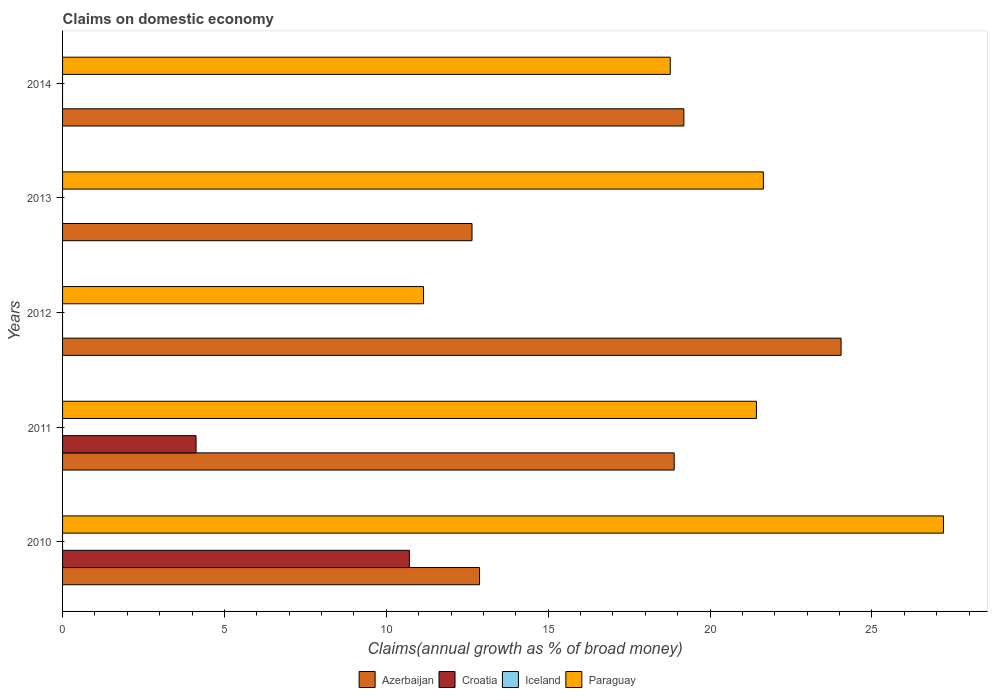How many groups of bars are there?
Give a very brief answer. 5. Are the number of bars per tick equal to the number of legend labels?
Offer a terse response. No. Are the number of bars on each tick of the Y-axis equal?
Your answer should be very brief. No. How many bars are there on the 3rd tick from the top?
Provide a succinct answer. 2. What is the label of the 1st group of bars from the top?
Your answer should be very brief. 2014. What is the percentage of broad money claimed on domestic economy in Azerbaijan in 2013?
Give a very brief answer. 12.65. Across all years, what is the maximum percentage of broad money claimed on domestic economy in Paraguay?
Offer a very short reply. 27.21. Across all years, what is the minimum percentage of broad money claimed on domestic economy in Paraguay?
Provide a short and direct response. 11.15. In which year was the percentage of broad money claimed on domestic economy in Azerbaijan maximum?
Offer a very short reply. 2012. What is the difference between the percentage of broad money claimed on domestic economy in Azerbaijan in 2010 and that in 2012?
Provide a short and direct response. -11.17. What is the difference between the percentage of broad money claimed on domestic economy in Croatia in 2010 and the percentage of broad money claimed on domestic economy in Azerbaijan in 2012?
Provide a succinct answer. -13.33. What is the average percentage of broad money claimed on domestic economy in Paraguay per year?
Your answer should be very brief. 20.04. In the year 2010, what is the difference between the percentage of broad money claimed on domestic economy in Paraguay and percentage of broad money claimed on domestic economy in Croatia?
Your response must be concise. 16.5. In how many years, is the percentage of broad money claimed on domestic economy in Iceland greater than 11 %?
Your response must be concise. 0. What is the ratio of the percentage of broad money claimed on domestic economy in Azerbaijan in 2010 to that in 2013?
Offer a terse response. 1.02. What is the difference between the highest and the second highest percentage of broad money claimed on domestic economy in Azerbaijan?
Ensure brevity in your answer.  4.86. What is the difference between the highest and the lowest percentage of broad money claimed on domestic economy in Paraguay?
Provide a short and direct response. 16.06. In how many years, is the percentage of broad money claimed on domestic economy in Azerbaijan greater than the average percentage of broad money claimed on domestic economy in Azerbaijan taken over all years?
Offer a terse response. 3. Is it the case that in every year, the sum of the percentage of broad money claimed on domestic economy in Iceland and percentage of broad money claimed on domestic economy in Paraguay is greater than the sum of percentage of broad money claimed on domestic economy in Azerbaijan and percentage of broad money claimed on domestic economy in Croatia?
Give a very brief answer. No. Are the values on the major ticks of X-axis written in scientific E-notation?
Your answer should be very brief. No. Does the graph contain any zero values?
Keep it short and to the point. Yes. Does the graph contain grids?
Keep it short and to the point. No. Where does the legend appear in the graph?
Make the answer very short. Bottom center. How are the legend labels stacked?
Give a very brief answer. Horizontal. What is the title of the graph?
Give a very brief answer. Claims on domestic economy. Does "Bahamas" appear as one of the legend labels in the graph?
Give a very brief answer. No. What is the label or title of the X-axis?
Your answer should be compact. Claims(annual growth as % of broad money). What is the Claims(annual growth as % of broad money) of Azerbaijan in 2010?
Keep it short and to the point. 12.88. What is the Claims(annual growth as % of broad money) of Croatia in 2010?
Ensure brevity in your answer.  10.71. What is the Claims(annual growth as % of broad money) of Iceland in 2010?
Your response must be concise. 0. What is the Claims(annual growth as % of broad money) of Paraguay in 2010?
Ensure brevity in your answer.  27.21. What is the Claims(annual growth as % of broad money) of Azerbaijan in 2011?
Keep it short and to the point. 18.89. What is the Claims(annual growth as % of broad money) in Croatia in 2011?
Keep it short and to the point. 4.12. What is the Claims(annual growth as % of broad money) in Paraguay in 2011?
Provide a succinct answer. 21.43. What is the Claims(annual growth as % of broad money) in Azerbaijan in 2012?
Provide a succinct answer. 24.05. What is the Claims(annual growth as % of broad money) in Croatia in 2012?
Your response must be concise. 0. What is the Claims(annual growth as % of broad money) of Paraguay in 2012?
Your answer should be compact. 11.15. What is the Claims(annual growth as % of broad money) in Azerbaijan in 2013?
Keep it short and to the point. 12.65. What is the Claims(annual growth as % of broad money) in Croatia in 2013?
Provide a short and direct response. 0. What is the Claims(annual growth as % of broad money) of Iceland in 2013?
Provide a succinct answer. 0. What is the Claims(annual growth as % of broad money) in Paraguay in 2013?
Ensure brevity in your answer.  21.65. What is the Claims(annual growth as % of broad money) in Azerbaijan in 2014?
Offer a terse response. 19.19. What is the Claims(annual growth as % of broad money) in Paraguay in 2014?
Offer a very short reply. 18.77. Across all years, what is the maximum Claims(annual growth as % of broad money) of Azerbaijan?
Your answer should be compact. 24.05. Across all years, what is the maximum Claims(annual growth as % of broad money) in Croatia?
Your answer should be compact. 10.71. Across all years, what is the maximum Claims(annual growth as % of broad money) of Paraguay?
Your answer should be very brief. 27.21. Across all years, what is the minimum Claims(annual growth as % of broad money) in Azerbaijan?
Give a very brief answer. 12.65. Across all years, what is the minimum Claims(annual growth as % of broad money) of Croatia?
Your response must be concise. 0. Across all years, what is the minimum Claims(annual growth as % of broad money) in Paraguay?
Provide a short and direct response. 11.15. What is the total Claims(annual growth as % of broad money) of Azerbaijan in the graph?
Keep it short and to the point. 87.66. What is the total Claims(annual growth as % of broad money) in Croatia in the graph?
Provide a succinct answer. 14.84. What is the total Claims(annual growth as % of broad money) of Paraguay in the graph?
Ensure brevity in your answer.  100.21. What is the difference between the Claims(annual growth as % of broad money) in Azerbaijan in 2010 and that in 2011?
Ensure brevity in your answer.  -6.01. What is the difference between the Claims(annual growth as % of broad money) of Croatia in 2010 and that in 2011?
Offer a terse response. 6.59. What is the difference between the Claims(annual growth as % of broad money) in Paraguay in 2010 and that in 2011?
Your answer should be very brief. 5.78. What is the difference between the Claims(annual growth as % of broad money) of Azerbaijan in 2010 and that in 2012?
Your response must be concise. -11.17. What is the difference between the Claims(annual growth as % of broad money) of Paraguay in 2010 and that in 2012?
Offer a very short reply. 16.06. What is the difference between the Claims(annual growth as % of broad money) of Azerbaijan in 2010 and that in 2013?
Your response must be concise. 0.23. What is the difference between the Claims(annual growth as % of broad money) in Paraguay in 2010 and that in 2013?
Ensure brevity in your answer.  5.56. What is the difference between the Claims(annual growth as % of broad money) of Azerbaijan in 2010 and that in 2014?
Your answer should be compact. -6.31. What is the difference between the Claims(annual growth as % of broad money) of Paraguay in 2010 and that in 2014?
Provide a short and direct response. 8.44. What is the difference between the Claims(annual growth as % of broad money) in Azerbaijan in 2011 and that in 2012?
Offer a very short reply. -5.16. What is the difference between the Claims(annual growth as % of broad money) in Paraguay in 2011 and that in 2012?
Ensure brevity in your answer.  10.28. What is the difference between the Claims(annual growth as % of broad money) of Azerbaijan in 2011 and that in 2013?
Provide a succinct answer. 6.25. What is the difference between the Claims(annual growth as % of broad money) of Paraguay in 2011 and that in 2013?
Make the answer very short. -0.22. What is the difference between the Claims(annual growth as % of broad money) in Azerbaijan in 2011 and that in 2014?
Offer a very short reply. -0.3. What is the difference between the Claims(annual growth as % of broad money) in Paraguay in 2011 and that in 2014?
Your answer should be compact. 2.66. What is the difference between the Claims(annual growth as % of broad money) in Paraguay in 2012 and that in 2013?
Ensure brevity in your answer.  -10.5. What is the difference between the Claims(annual growth as % of broad money) in Azerbaijan in 2012 and that in 2014?
Provide a short and direct response. 4.86. What is the difference between the Claims(annual growth as % of broad money) in Paraguay in 2012 and that in 2014?
Offer a very short reply. -7.62. What is the difference between the Claims(annual growth as % of broad money) of Azerbaijan in 2013 and that in 2014?
Make the answer very short. -6.54. What is the difference between the Claims(annual growth as % of broad money) in Paraguay in 2013 and that in 2014?
Your answer should be compact. 2.88. What is the difference between the Claims(annual growth as % of broad money) in Azerbaijan in 2010 and the Claims(annual growth as % of broad money) in Croatia in 2011?
Make the answer very short. 8.76. What is the difference between the Claims(annual growth as % of broad money) of Azerbaijan in 2010 and the Claims(annual growth as % of broad money) of Paraguay in 2011?
Your response must be concise. -8.55. What is the difference between the Claims(annual growth as % of broad money) of Croatia in 2010 and the Claims(annual growth as % of broad money) of Paraguay in 2011?
Keep it short and to the point. -10.72. What is the difference between the Claims(annual growth as % of broad money) of Azerbaijan in 2010 and the Claims(annual growth as % of broad money) of Paraguay in 2012?
Your answer should be compact. 1.73. What is the difference between the Claims(annual growth as % of broad money) in Croatia in 2010 and the Claims(annual growth as % of broad money) in Paraguay in 2012?
Make the answer very short. -0.44. What is the difference between the Claims(annual growth as % of broad money) in Azerbaijan in 2010 and the Claims(annual growth as % of broad money) in Paraguay in 2013?
Your response must be concise. -8.77. What is the difference between the Claims(annual growth as % of broad money) of Croatia in 2010 and the Claims(annual growth as % of broad money) of Paraguay in 2013?
Your answer should be very brief. -10.93. What is the difference between the Claims(annual growth as % of broad money) of Azerbaijan in 2010 and the Claims(annual growth as % of broad money) of Paraguay in 2014?
Keep it short and to the point. -5.89. What is the difference between the Claims(annual growth as % of broad money) of Croatia in 2010 and the Claims(annual growth as % of broad money) of Paraguay in 2014?
Offer a very short reply. -8.06. What is the difference between the Claims(annual growth as % of broad money) of Azerbaijan in 2011 and the Claims(annual growth as % of broad money) of Paraguay in 2012?
Your response must be concise. 7.74. What is the difference between the Claims(annual growth as % of broad money) of Croatia in 2011 and the Claims(annual growth as % of broad money) of Paraguay in 2012?
Give a very brief answer. -7.03. What is the difference between the Claims(annual growth as % of broad money) of Azerbaijan in 2011 and the Claims(annual growth as % of broad money) of Paraguay in 2013?
Your answer should be very brief. -2.75. What is the difference between the Claims(annual growth as % of broad money) of Croatia in 2011 and the Claims(annual growth as % of broad money) of Paraguay in 2013?
Provide a short and direct response. -17.52. What is the difference between the Claims(annual growth as % of broad money) of Azerbaijan in 2011 and the Claims(annual growth as % of broad money) of Paraguay in 2014?
Your answer should be very brief. 0.12. What is the difference between the Claims(annual growth as % of broad money) in Croatia in 2011 and the Claims(annual growth as % of broad money) in Paraguay in 2014?
Give a very brief answer. -14.65. What is the difference between the Claims(annual growth as % of broad money) of Azerbaijan in 2012 and the Claims(annual growth as % of broad money) of Paraguay in 2013?
Keep it short and to the point. 2.4. What is the difference between the Claims(annual growth as % of broad money) in Azerbaijan in 2012 and the Claims(annual growth as % of broad money) in Paraguay in 2014?
Provide a succinct answer. 5.28. What is the difference between the Claims(annual growth as % of broad money) in Azerbaijan in 2013 and the Claims(annual growth as % of broad money) in Paraguay in 2014?
Your answer should be very brief. -6.12. What is the average Claims(annual growth as % of broad money) of Azerbaijan per year?
Make the answer very short. 17.53. What is the average Claims(annual growth as % of broad money) of Croatia per year?
Offer a terse response. 2.97. What is the average Claims(annual growth as % of broad money) of Iceland per year?
Provide a succinct answer. 0. What is the average Claims(annual growth as % of broad money) in Paraguay per year?
Your response must be concise. 20.04. In the year 2010, what is the difference between the Claims(annual growth as % of broad money) in Azerbaijan and Claims(annual growth as % of broad money) in Croatia?
Keep it short and to the point. 2.17. In the year 2010, what is the difference between the Claims(annual growth as % of broad money) of Azerbaijan and Claims(annual growth as % of broad money) of Paraguay?
Keep it short and to the point. -14.33. In the year 2010, what is the difference between the Claims(annual growth as % of broad money) in Croatia and Claims(annual growth as % of broad money) in Paraguay?
Give a very brief answer. -16.5. In the year 2011, what is the difference between the Claims(annual growth as % of broad money) in Azerbaijan and Claims(annual growth as % of broad money) in Croatia?
Offer a very short reply. 14.77. In the year 2011, what is the difference between the Claims(annual growth as % of broad money) of Azerbaijan and Claims(annual growth as % of broad money) of Paraguay?
Your answer should be compact. -2.54. In the year 2011, what is the difference between the Claims(annual growth as % of broad money) in Croatia and Claims(annual growth as % of broad money) in Paraguay?
Keep it short and to the point. -17.31. In the year 2012, what is the difference between the Claims(annual growth as % of broad money) in Azerbaijan and Claims(annual growth as % of broad money) in Paraguay?
Offer a very short reply. 12.9. In the year 2014, what is the difference between the Claims(annual growth as % of broad money) in Azerbaijan and Claims(annual growth as % of broad money) in Paraguay?
Offer a terse response. 0.42. What is the ratio of the Claims(annual growth as % of broad money) in Azerbaijan in 2010 to that in 2011?
Ensure brevity in your answer.  0.68. What is the ratio of the Claims(annual growth as % of broad money) in Croatia in 2010 to that in 2011?
Give a very brief answer. 2.6. What is the ratio of the Claims(annual growth as % of broad money) of Paraguay in 2010 to that in 2011?
Your response must be concise. 1.27. What is the ratio of the Claims(annual growth as % of broad money) of Azerbaijan in 2010 to that in 2012?
Provide a short and direct response. 0.54. What is the ratio of the Claims(annual growth as % of broad money) in Paraguay in 2010 to that in 2012?
Your answer should be very brief. 2.44. What is the ratio of the Claims(annual growth as % of broad money) in Azerbaijan in 2010 to that in 2013?
Provide a short and direct response. 1.02. What is the ratio of the Claims(annual growth as % of broad money) in Paraguay in 2010 to that in 2013?
Provide a short and direct response. 1.26. What is the ratio of the Claims(annual growth as % of broad money) of Azerbaijan in 2010 to that in 2014?
Make the answer very short. 0.67. What is the ratio of the Claims(annual growth as % of broad money) in Paraguay in 2010 to that in 2014?
Ensure brevity in your answer.  1.45. What is the ratio of the Claims(annual growth as % of broad money) in Azerbaijan in 2011 to that in 2012?
Make the answer very short. 0.79. What is the ratio of the Claims(annual growth as % of broad money) of Paraguay in 2011 to that in 2012?
Your response must be concise. 1.92. What is the ratio of the Claims(annual growth as % of broad money) in Azerbaijan in 2011 to that in 2013?
Give a very brief answer. 1.49. What is the ratio of the Claims(annual growth as % of broad money) of Azerbaijan in 2011 to that in 2014?
Your answer should be very brief. 0.98. What is the ratio of the Claims(annual growth as % of broad money) in Paraguay in 2011 to that in 2014?
Your response must be concise. 1.14. What is the ratio of the Claims(annual growth as % of broad money) of Azerbaijan in 2012 to that in 2013?
Provide a short and direct response. 1.9. What is the ratio of the Claims(annual growth as % of broad money) of Paraguay in 2012 to that in 2013?
Give a very brief answer. 0.52. What is the ratio of the Claims(annual growth as % of broad money) of Azerbaijan in 2012 to that in 2014?
Offer a very short reply. 1.25. What is the ratio of the Claims(annual growth as % of broad money) of Paraguay in 2012 to that in 2014?
Offer a very short reply. 0.59. What is the ratio of the Claims(annual growth as % of broad money) of Azerbaijan in 2013 to that in 2014?
Offer a terse response. 0.66. What is the ratio of the Claims(annual growth as % of broad money) of Paraguay in 2013 to that in 2014?
Your response must be concise. 1.15. What is the difference between the highest and the second highest Claims(annual growth as % of broad money) of Azerbaijan?
Offer a very short reply. 4.86. What is the difference between the highest and the second highest Claims(annual growth as % of broad money) of Paraguay?
Your response must be concise. 5.56. What is the difference between the highest and the lowest Claims(annual growth as % of broad money) of Croatia?
Give a very brief answer. 10.71. What is the difference between the highest and the lowest Claims(annual growth as % of broad money) of Paraguay?
Offer a terse response. 16.06. 